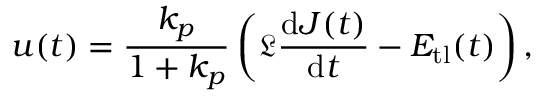Convert formula to latex. <formula><loc_0><loc_0><loc_500><loc_500>u ( t ) = \frac { k _ { p } } { 1 + k _ { p } } \left ( \mathfrak { L } \frac { d J ( t ) } { d t } - E _ { t l } ( t ) \right ) ,</formula> 